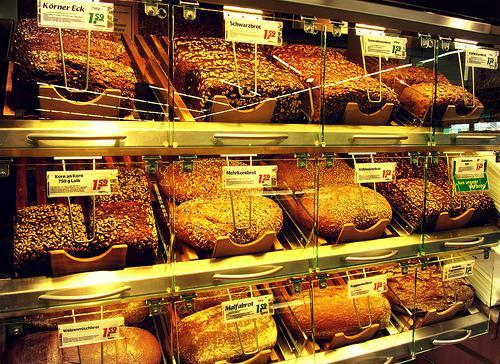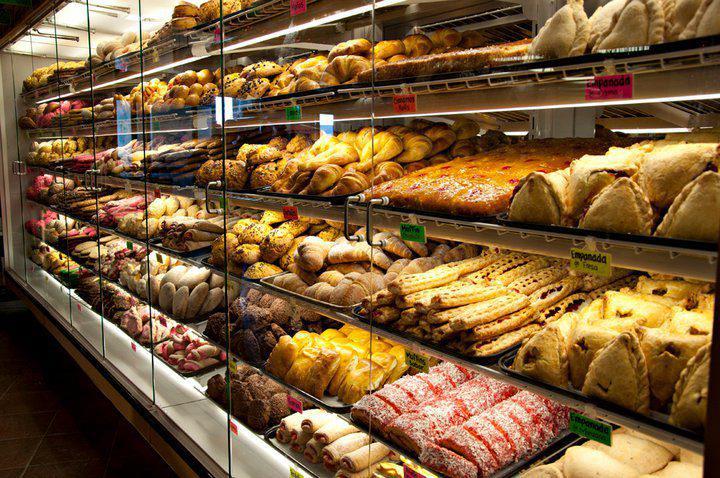The first image is the image on the left, the second image is the image on the right. Examine the images to the left and right. Is the description "There are visible workers behind the the bakers cookie and brownie display case." accurate? Answer yes or no. No. The first image is the image on the left, the second image is the image on the right. Considering the images on both sides, is "Only one person is visible in the image." valid? Answer yes or no. No. 